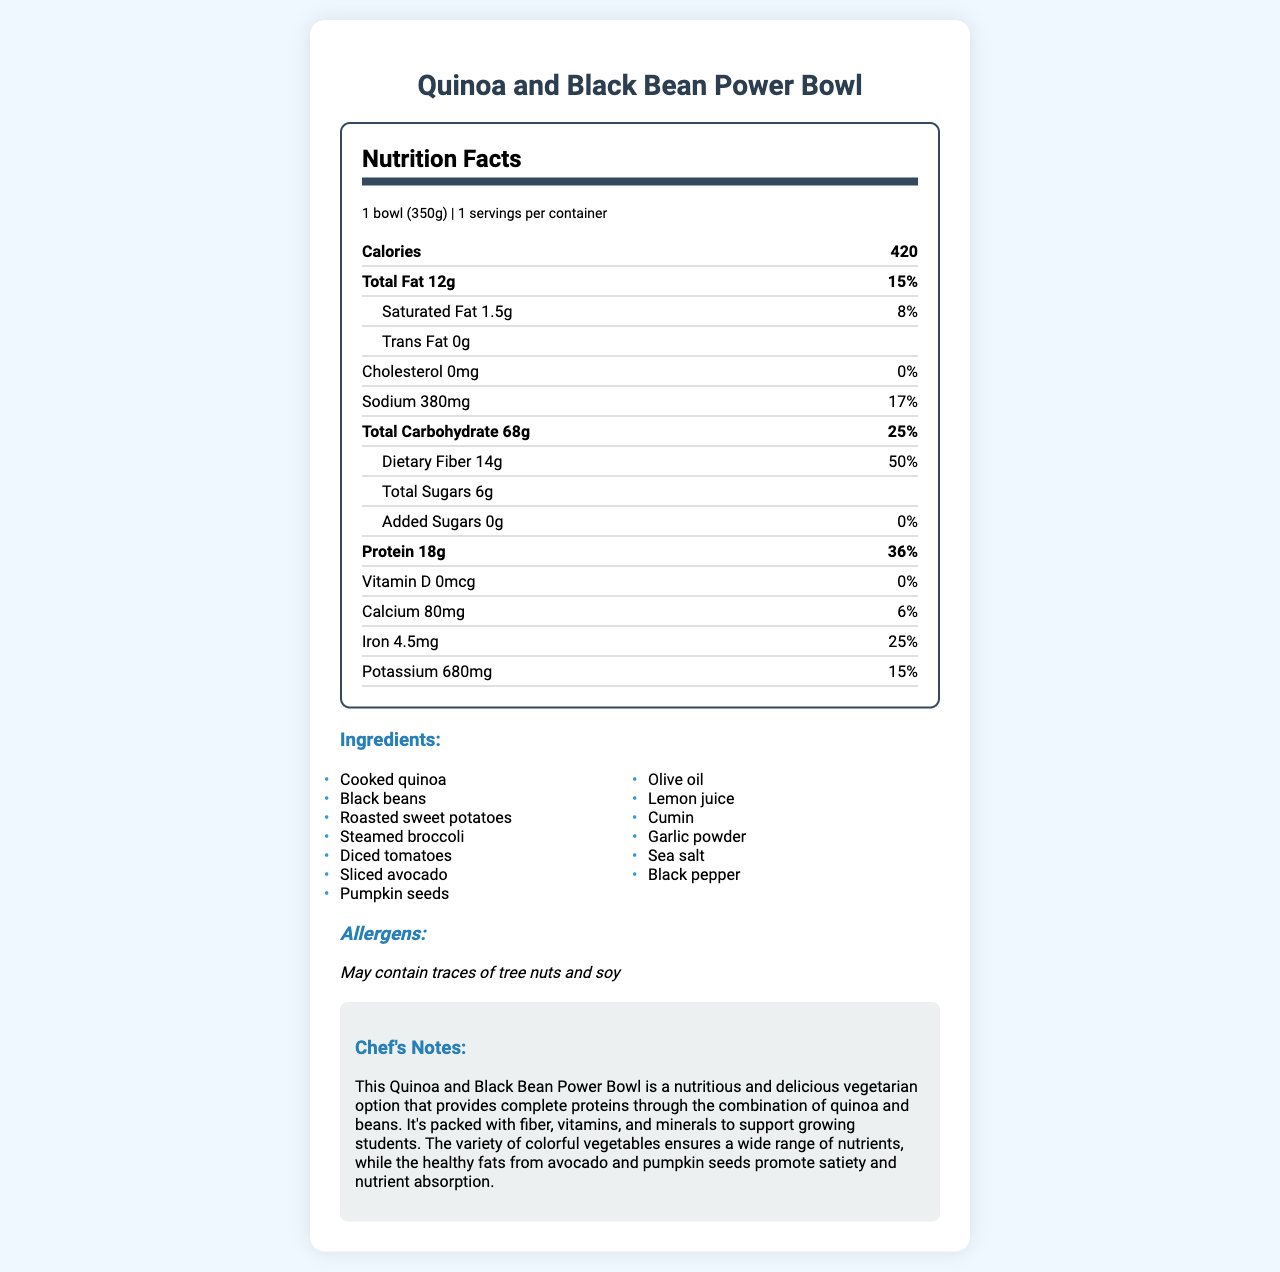What is the serving size of the Quinoa and Black Bean Power Bowl? The serving size is clearly indicated as "1 bowl (350g)" in the serving information section at the top of the nutrition label.
Answer: 1 bowl (350g) How many calories are in one serving of the Quinoa and Black Bean Power Bowl? The calorie count is prominently displayed in the bold section, showing 420 calories per serving.
Answer: 420 What is the total amount of dietary fiber in the Power Bowl, and what is its daily value percentage? The dietary fiber amount and its daily value percentage are listed under the "Total Carbohydrate" section, showing 14g and 50% respectively.
Answer: 14g, 50% Does the Quinoa and Black Bean Power Bowl contain any added sugars? The label indicates 0g of added sugars with a daily value of 0%.
Answer: No List at least three main vegetables included in the ingredients of the Power Bowl. These vegetables are listed as part of the ingredients in the document.
Answer: Roasted sweet potatoes, steamed broccoli, diced tomatoes Which mineral has the highest daily value percentage in the Power Bowl? The dietary fiber has the highest daily value percentage at 50%, as listed in the "Total Carbohydrate" section.
Answer: Dietary fiber (50%) How much protein is in the Power Bowl, and what percentage of the daily value does it represent? The protein content is shown as 18g, which represents 36% of the daily value.
Answer: 18g, 36% What potential allergens should people be aware of when consuming this Power Bowl? A. Dairy B. Tree nuts C. Gluten D. Soy The label states "May contain traces of tree nuts and soy," indicating the potential allergens.
Answer: B, D What percentage of the daily value of sodium does one serving of the Power Bowl contain? The sodium content and its daily value percentage are listed, showing 380mg and 17%, respectively.
Answer: 17% Is this Quinoa and Black Bean Power Bowl suitable for a vegetarian diet? The ingredients listed do not include any meat products, making it suitable for a vegetarian diet.
Answer: Yes Summarize the main nutritional benefits provided by the Quinoa and Black Bean Power Bowl. The summary captures the main nutritional highlights, mentioning protein, fiber, vegetables, and healthy fats, similar to the chef's notes.
Answer: The Quinoa and Black Bean Power Bowl is a nutritious vegetarian option that offers a good balance of macronutrients, including 18g of protein and 14g of dietary fiber, which accounts for 36% and 50% of their daily values, respectively. It contains a variety of colorful vegetables and healthy fats, making it a well-rounded meal suitable for supporting children's growth and nutrient absorption. Does the Power Bowl contain any cholesterol? The nutrition label specifies that the cholesterol amount is 0mg, with a daily value of 0%.
Answer: No What is the main source of healthy fats in the Power Bowl? As mentioned in the chef's notes, the avocado and pumpkin seeds are the primary sources of healthy fats in this Power Bowl.
Answer: Avocado and pumpkin seeds Does the Power Bowl provide any Vitamin D? The label indicates that the Vitamin D content is 0mcg, with a daily value of 0%.
Answer: No Who is the chef responsible for the creation of this Quinoa and Black Bean Power Bowl? The document provides chef's notes but does not specify the name of the chef responsible for its creation.
Answer: Not enough information 